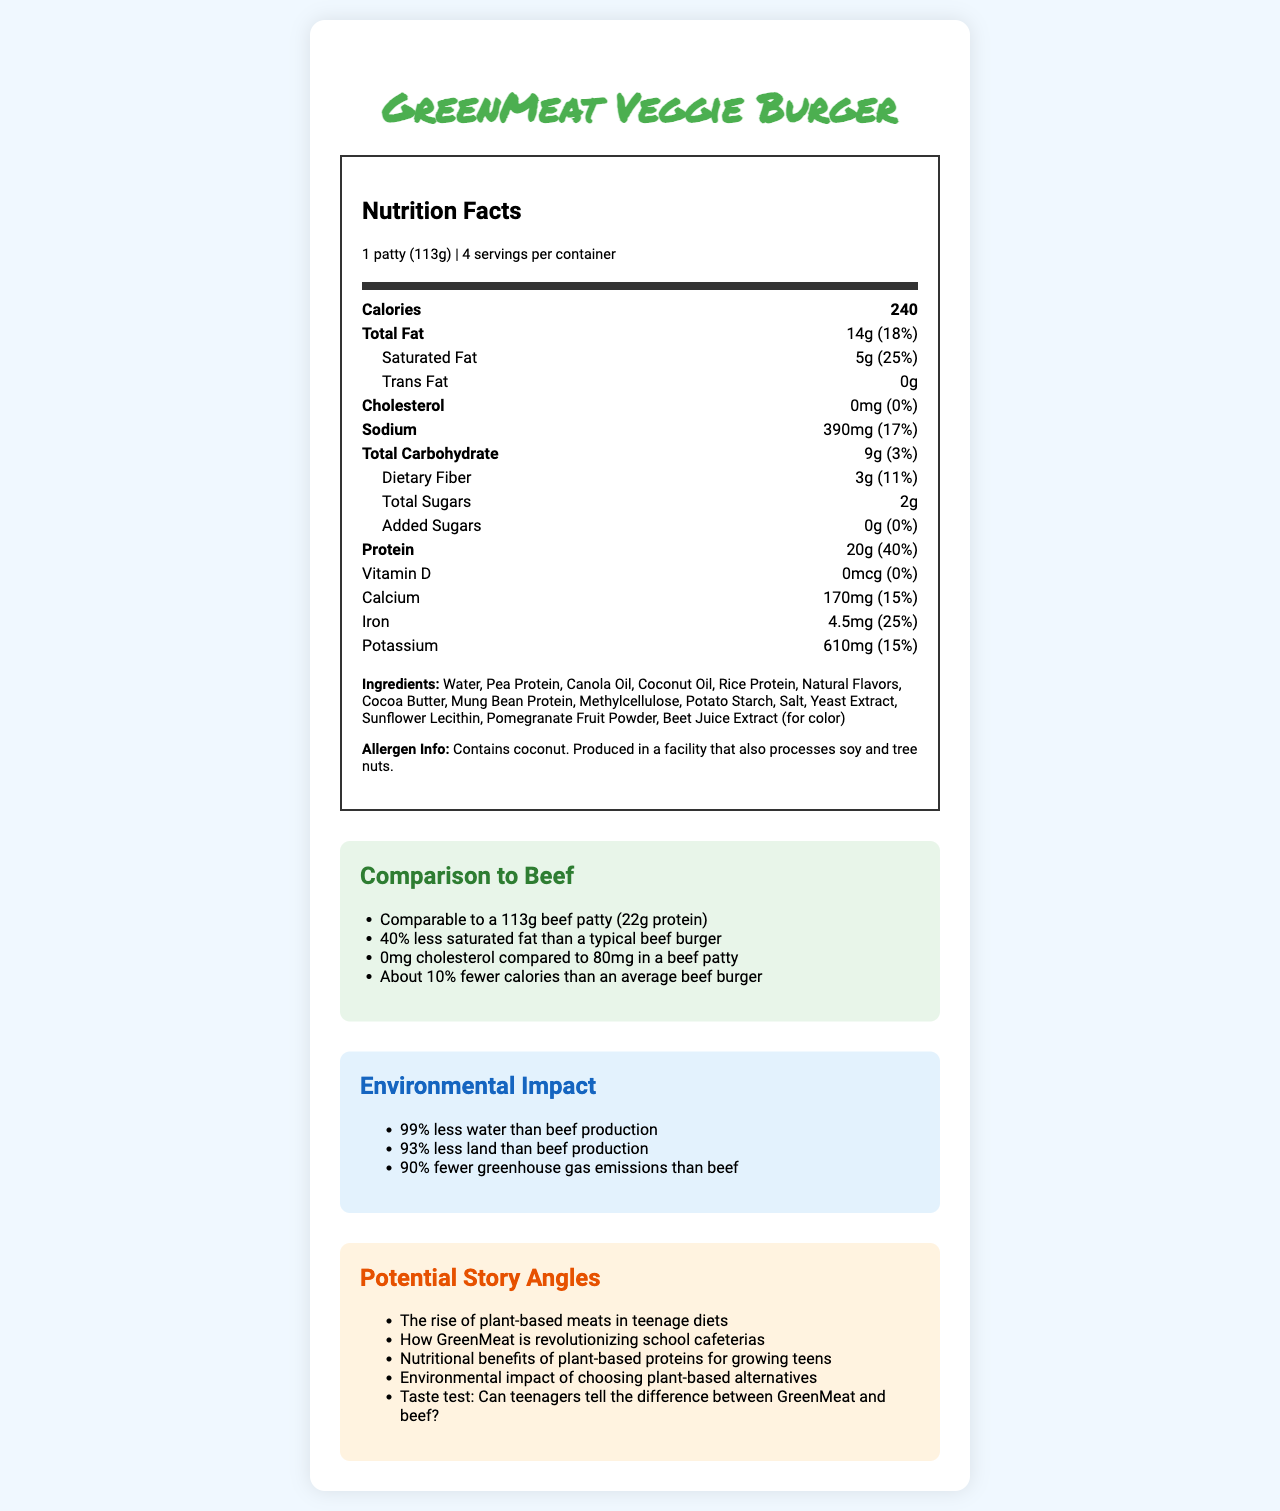what is the serving size of the GreenMeat Veggie Burger? The document states "1 patty (113g)" under the serving size.
Answer: 1 patty (113g) how many calories are in one serving? The document mentions "240 Calories" for one serving.
Answer: 240 how many grams of total fat are in one serving? "Total Fat" is listed as "14g".
Answer: 14g what percentage of the daily value of sodium does one serving contain? Under "Sodium," it says "17%" for the percent daily value.
Answer: 17% which ingredients are included in the GreenMeat Veggie Burger? The document lists all these ingredients under the "Ingredients" section.
Answer: Water, Pea Protein, Canola Oil, Coconut Oil, Rice Protein, Natural Flavors, Cocoa Butter, Mung Bean Protein, Methylcellulose, Potato Starch, Salt, Yeast Extract, Sunflower Lecithin, Pomegranate Fruit Powder, Beet Juice Extract (for color) how much fiber is in one serving of the GreenMeat Veggie Burger? The amount of dietary fiber is listed as "3g".
Answer: 3g how does the protein content of the GreenMeat Veggie Burger compare to a 113g beef patty? A. Less than beef B. Equal to beef C. More than beef D. Cannot be determined The document states that the protein content is comparable to a 113g beef patty with 22g of protein.
Answer: B. Equal to beef what is the daily value percentage of iron in one serving of the GreenMeat Veggie Burger? A. 15% B. 25% C. 40% D. 0% The document specifies "25%" as the daily value percentage for iron.
Answer: B. 25% how many servings are there per container? Under the serving size information, the document states "4 servings per container."
Answer: 4 is the GreenMeat Veggie Burger cholesterol-free? The document indicates "0mg" and "0%" for cholesterol, meaning it is cholesterol-free.
Answer: Yes describe the main comparison points between GreenMeat and a beef patty mentioned in the document. The comparison section highlights these main points about protein, fat content, cholesterol, and calorie differences.
Answer: The GreenMeat Veggie Burger is comparable in protein content to a 113g beef patty, has 40% less saturated fat, contains 0mg cholesterol compared to 80mg in a beef patty, and has about 10% fewer calories. which environmental benefit is NOT listed for GreenMeat Veggie Burger production compared to beef? The document lists three benefits: 99% less water usage, 93% less land use, and 90% fewer greenhouse gas emissions. Any other potential benefits are not mentioned.
Answer: Cannot be determined how much calcium is in one serving of the GreenMeat Veggie Burger? The document lists "170mg" under calcium content per serving.
Answer: 170mg what story angles could a journalist explore based on this document? The document provides a list of potential journalistic angles in a dedicated section.
Answer: The rise of plant-based meats in teenage diets, How GreenMeat is revolutionizing school cafeterias, Nutritional benefits of plant-based proteins for growing teens, Environmental impact of choosing plant-based alternatives, Taste test: Can teenagers tell the difference between GreenMeat and beef? does the GreenMeat Veggie Burger contain coconut? The allergen information states that the product contains coconut.
Answer: Yes 